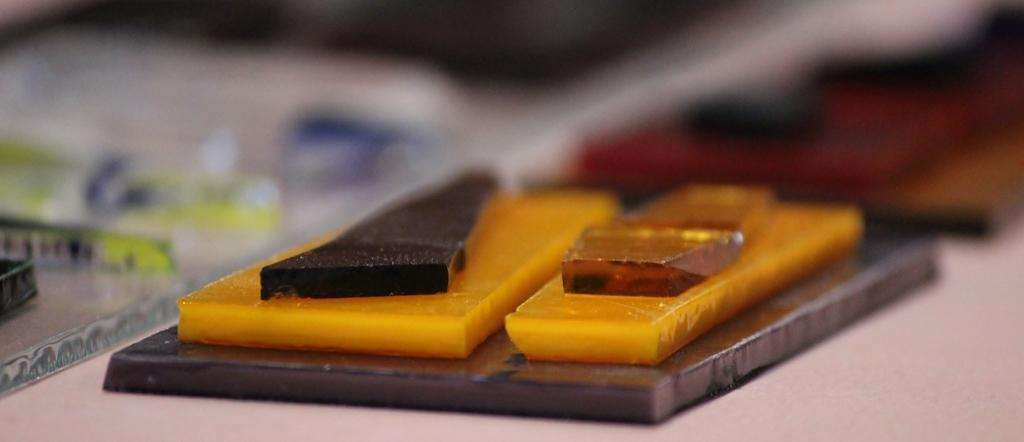What color are the objects in the image? The objects in the image are yellow. What is the surface on which the objects are placed? The objects are placed on a black surface. Can you describe the background of the image? The background of the image is blurred. What type of teeth can be seen in the image? There are no teeth present in the image; it features yellow objects on a black surface with a blurred background. 